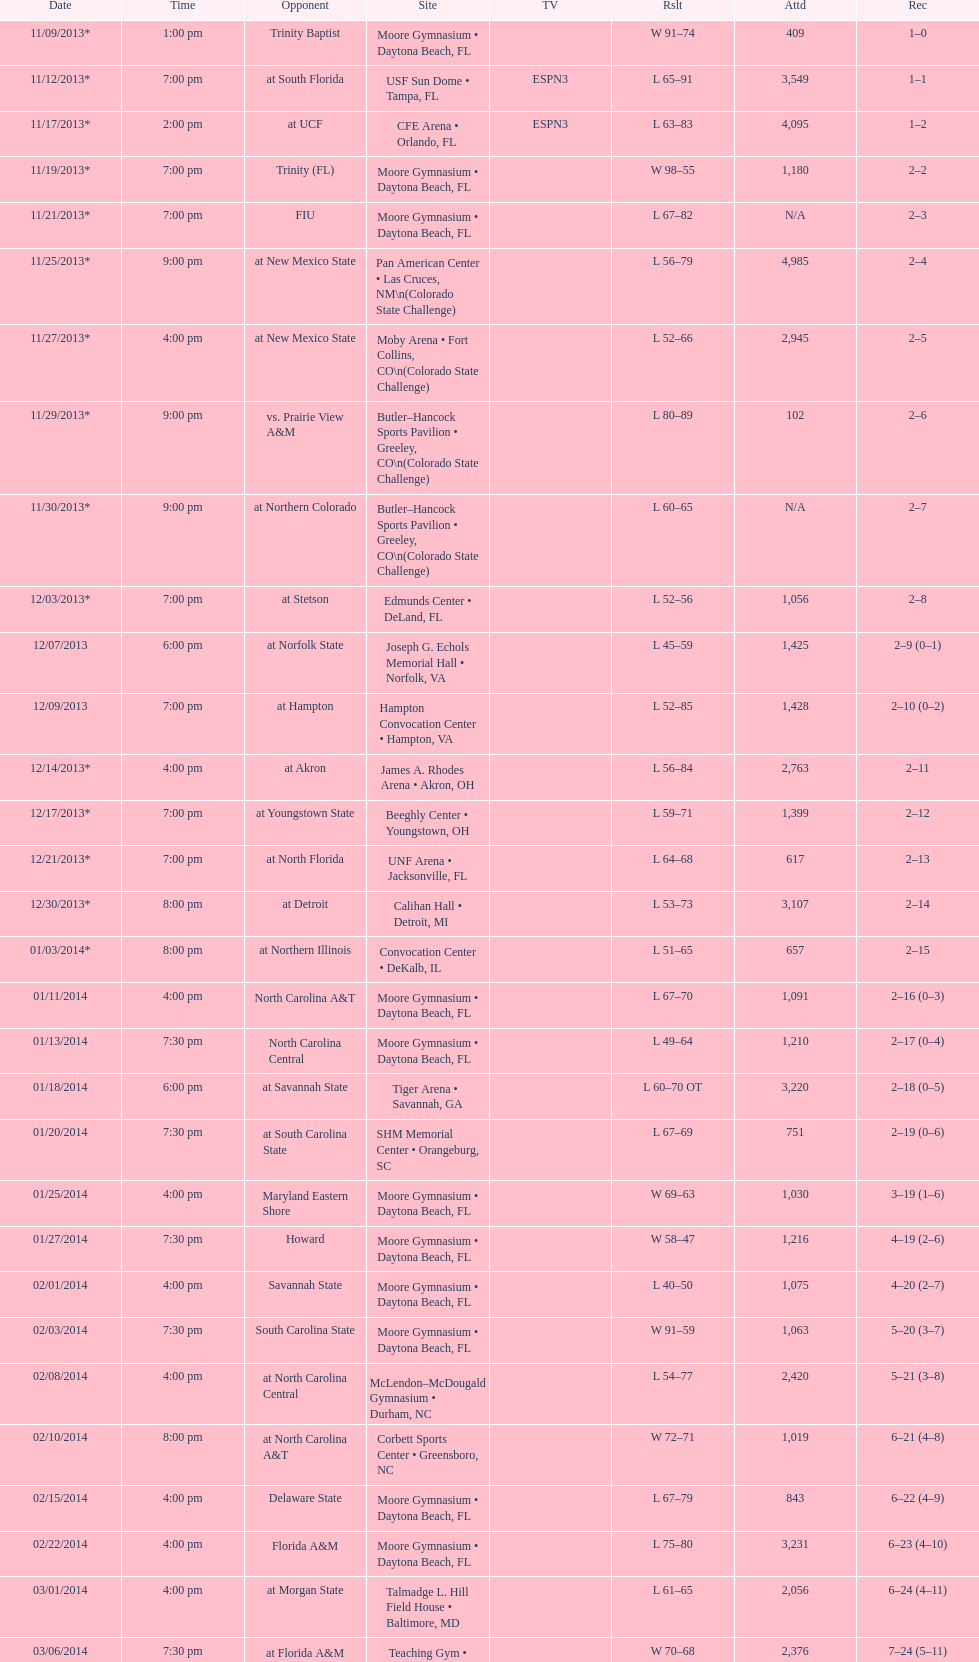How many games did the wildcats play in daytona beach, fl? 11. 